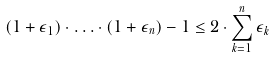<formula> <loc_0><loc_0><loc_500><loc_500>( 1 + \epsilon _ { 1 } ) \cdot { \dots } \cdot ( 1 + \epsilon _ { n } ) - 1 \leq 2 \cdot \sum _ { k = 1 } ^ { n } \epsilon _ { k }</formula> 